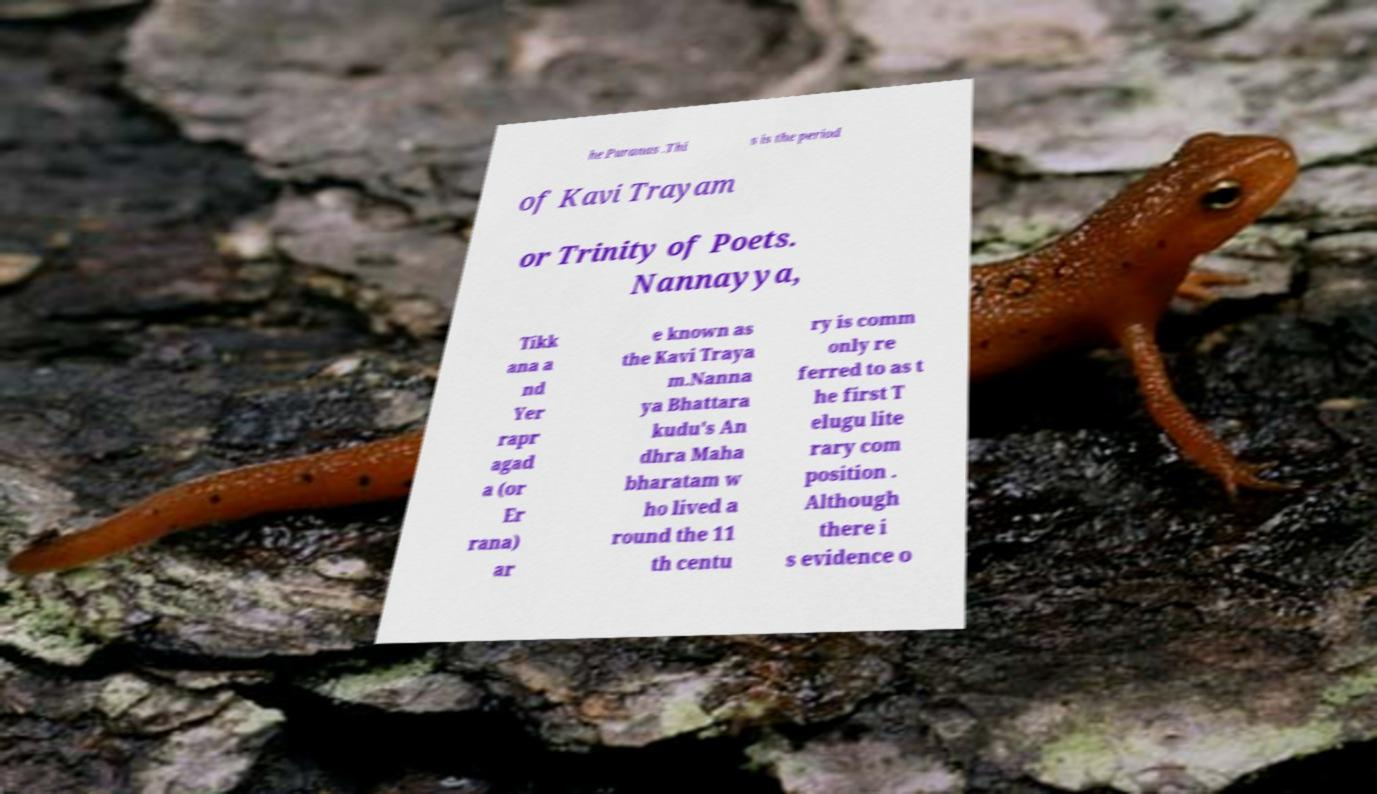Can you accurately transcribe the text from the provided image for me? he Puranas .Thi s is the period of Kavi Trayam or Trinity of Poets. Nannayya, Tikk ana a nd Yer rapr agad a (or Er rana) ar e known as the Kavi Traya m.Nanna ya Bhattara kudu's An dhra Maha bharatam w ho lived a round the 11 th centu ry is comm only re ferred to as t he first T elugu lite rary com position . Although there i s evidence o 